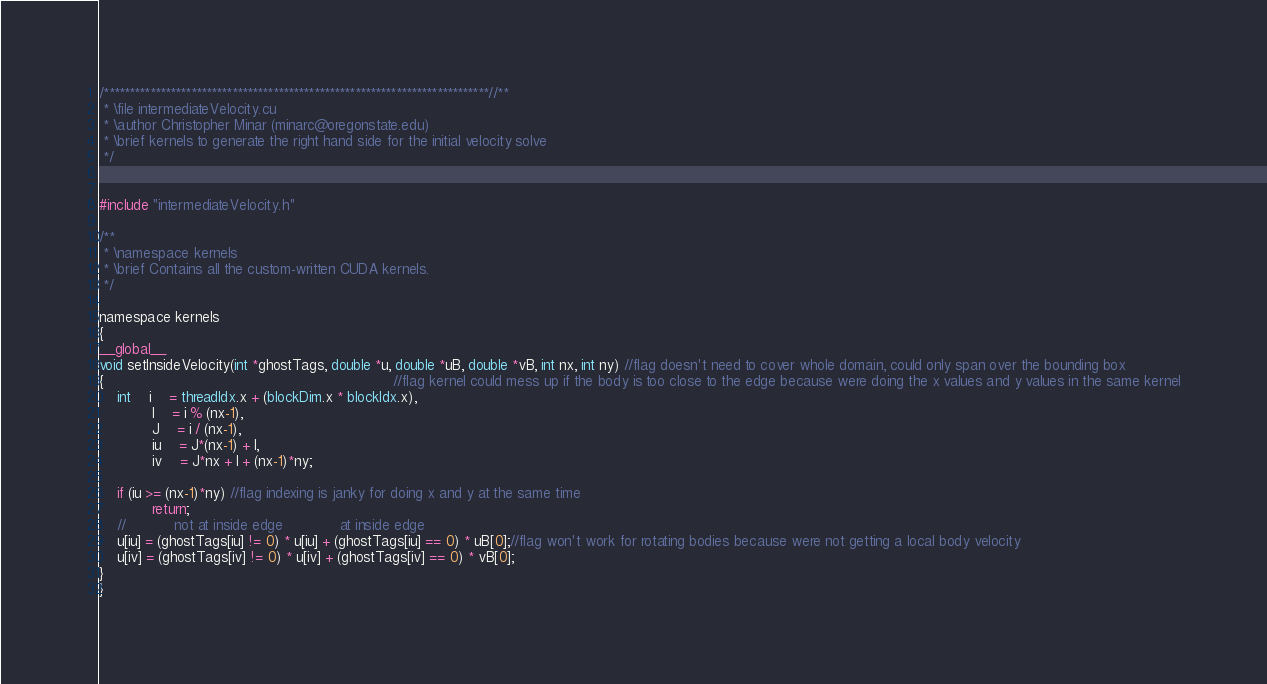Convert code to text. <code><loc_0><loc_0><loc_500><loc_500><_Cuda_>/***************************************************************************//**
 * \file intermediateVelocity.cu
 * \author Christopher Minar (minarc@oregonstate.edu)
 * \brief kernels to generate the right hand side for the initial velocity solve
 */


#include "intermediateVelocity.h"

/**
 * \namespace kernels
 * \brief Contains all the custom-written CUDA kernels.
 */

namespace kernels
{
__global__
void setInsideVelocity(int *ghostTags, double *u, double *uB, double *vB, int nx, int ny) //flag doesn't need to cover whole domain, could only span over the bounding box
{																  //flag kernel could mess up if the body is too close to the edge because were doing the x values and y values in the same kernel
	int 	i 	= threadIdx.x + (blockDim.x * blockIdx.x),
			I	= i % (nx-1),
			J	= i / (nx-1),
			iu	= J*(nx-1) + I,
			iv	= J*nx + I + (nx-1)*ny;

	if (iu >= (nx-1)*ny) //flag indexing is janky for doing x and y at the same time
			return;
	//			 not at inside edge             at inside edge
	u[iu] = (ghostTags[iu] != 0) * u[iu] + (ghostTags[iu] == 0) * uB[0];//flag won't work for rotating bodies because were not getting a local body velocity
	u[iv] = (ghostTags[iv] != 0) * u[iv] + (ghostTags[iv] == 0) * vB[0];
}
}
</code> 